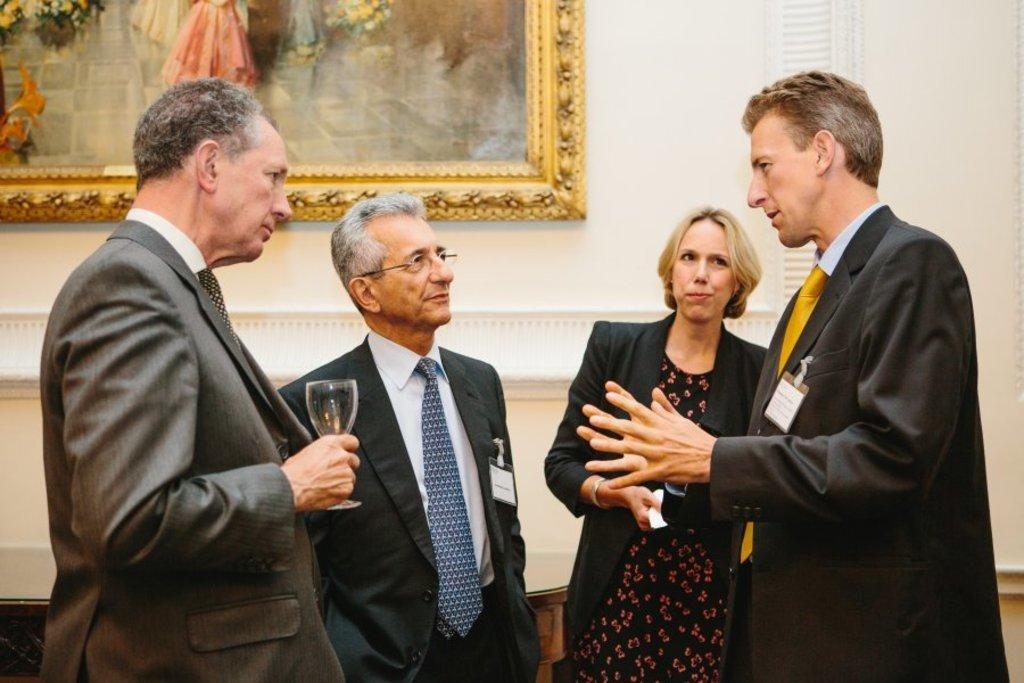How would you summarize this image in a sentence or two? Here we can see four people. This person is holding a glass. These people wore suits. Picture is on the white wall. These three people are looking at this man.  